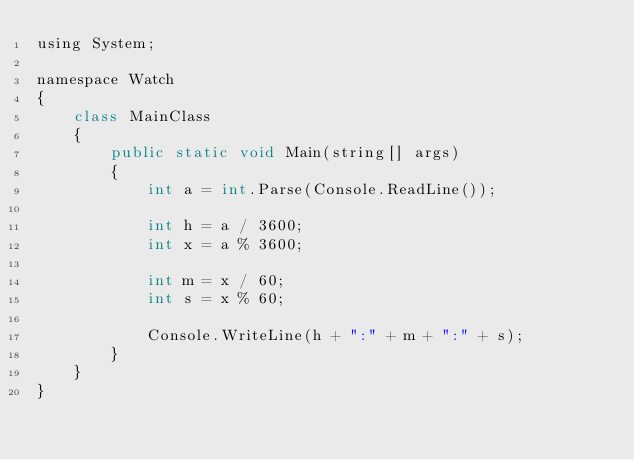<code> <loc_0><loc_0><loc_500><loc_500><_Java_>using System;
 
namespace Watch
{
    class MainClass
    {
        public static void Main(string[] args)
        {
            int a = int.Parse(Console.ReadLine());
 
            int h = a / 3600;
            int x = a % 3600;
 
            int m = x / 60;
            int s = x % 60;
 
            Console.WriteLine(h + ":" + m + ":" + s);
        }
    }
}</code> 